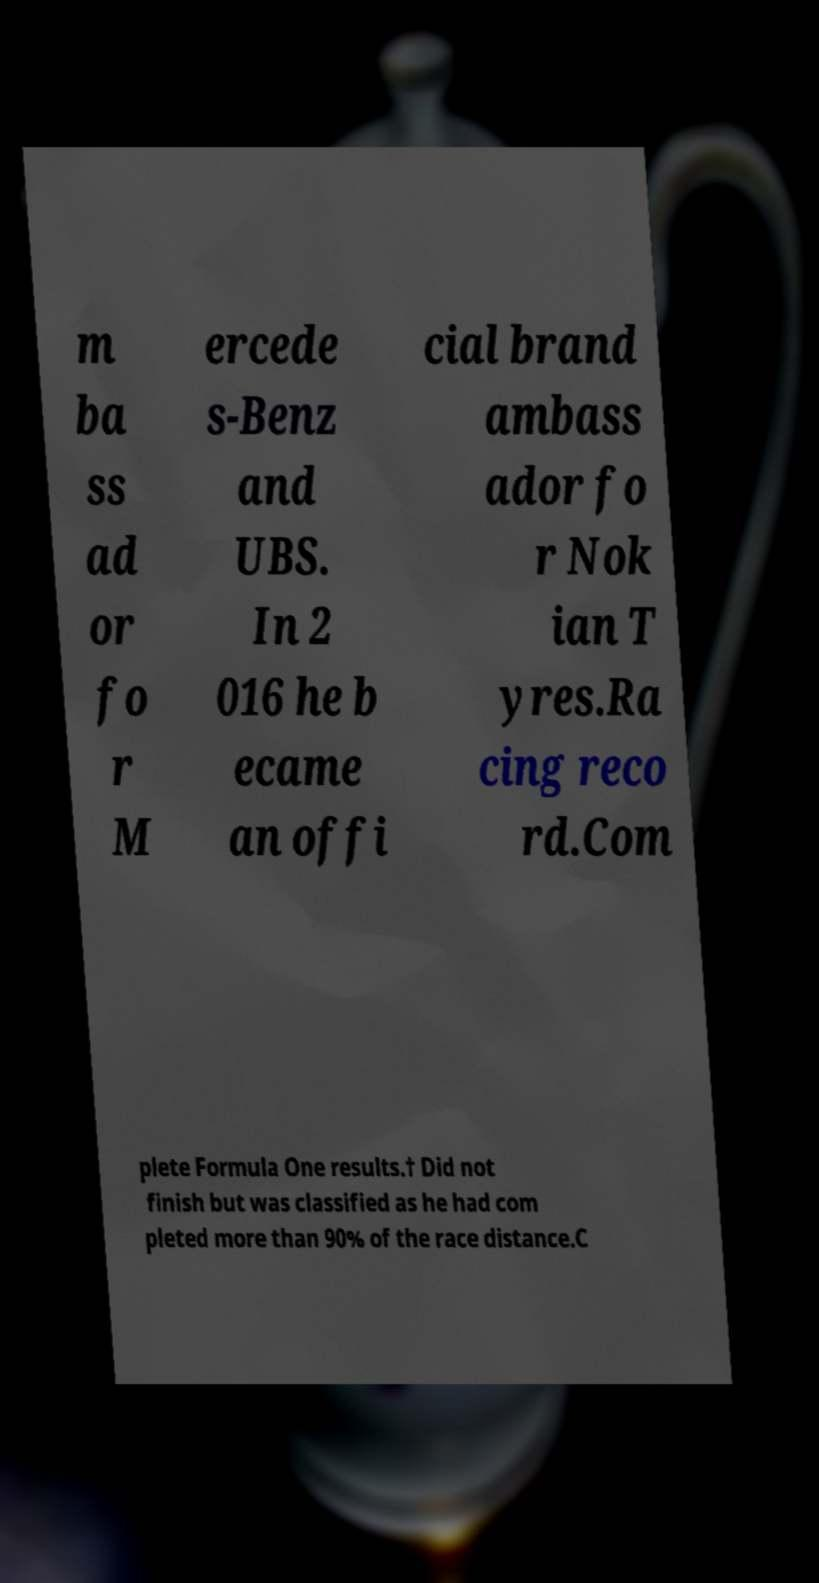I need the written content from this picture converted into text. Can you do that? m ba ss ad or fo r M ercede s-Benz and UBS. In 2 016 he b ecame an offi cial brand ambass ador fo r Nok ian T yres.Ra cing reco rd.Com plete Formula One results.† Did not finish but was classified as he had com pleted more than 90% of the race distance.C 